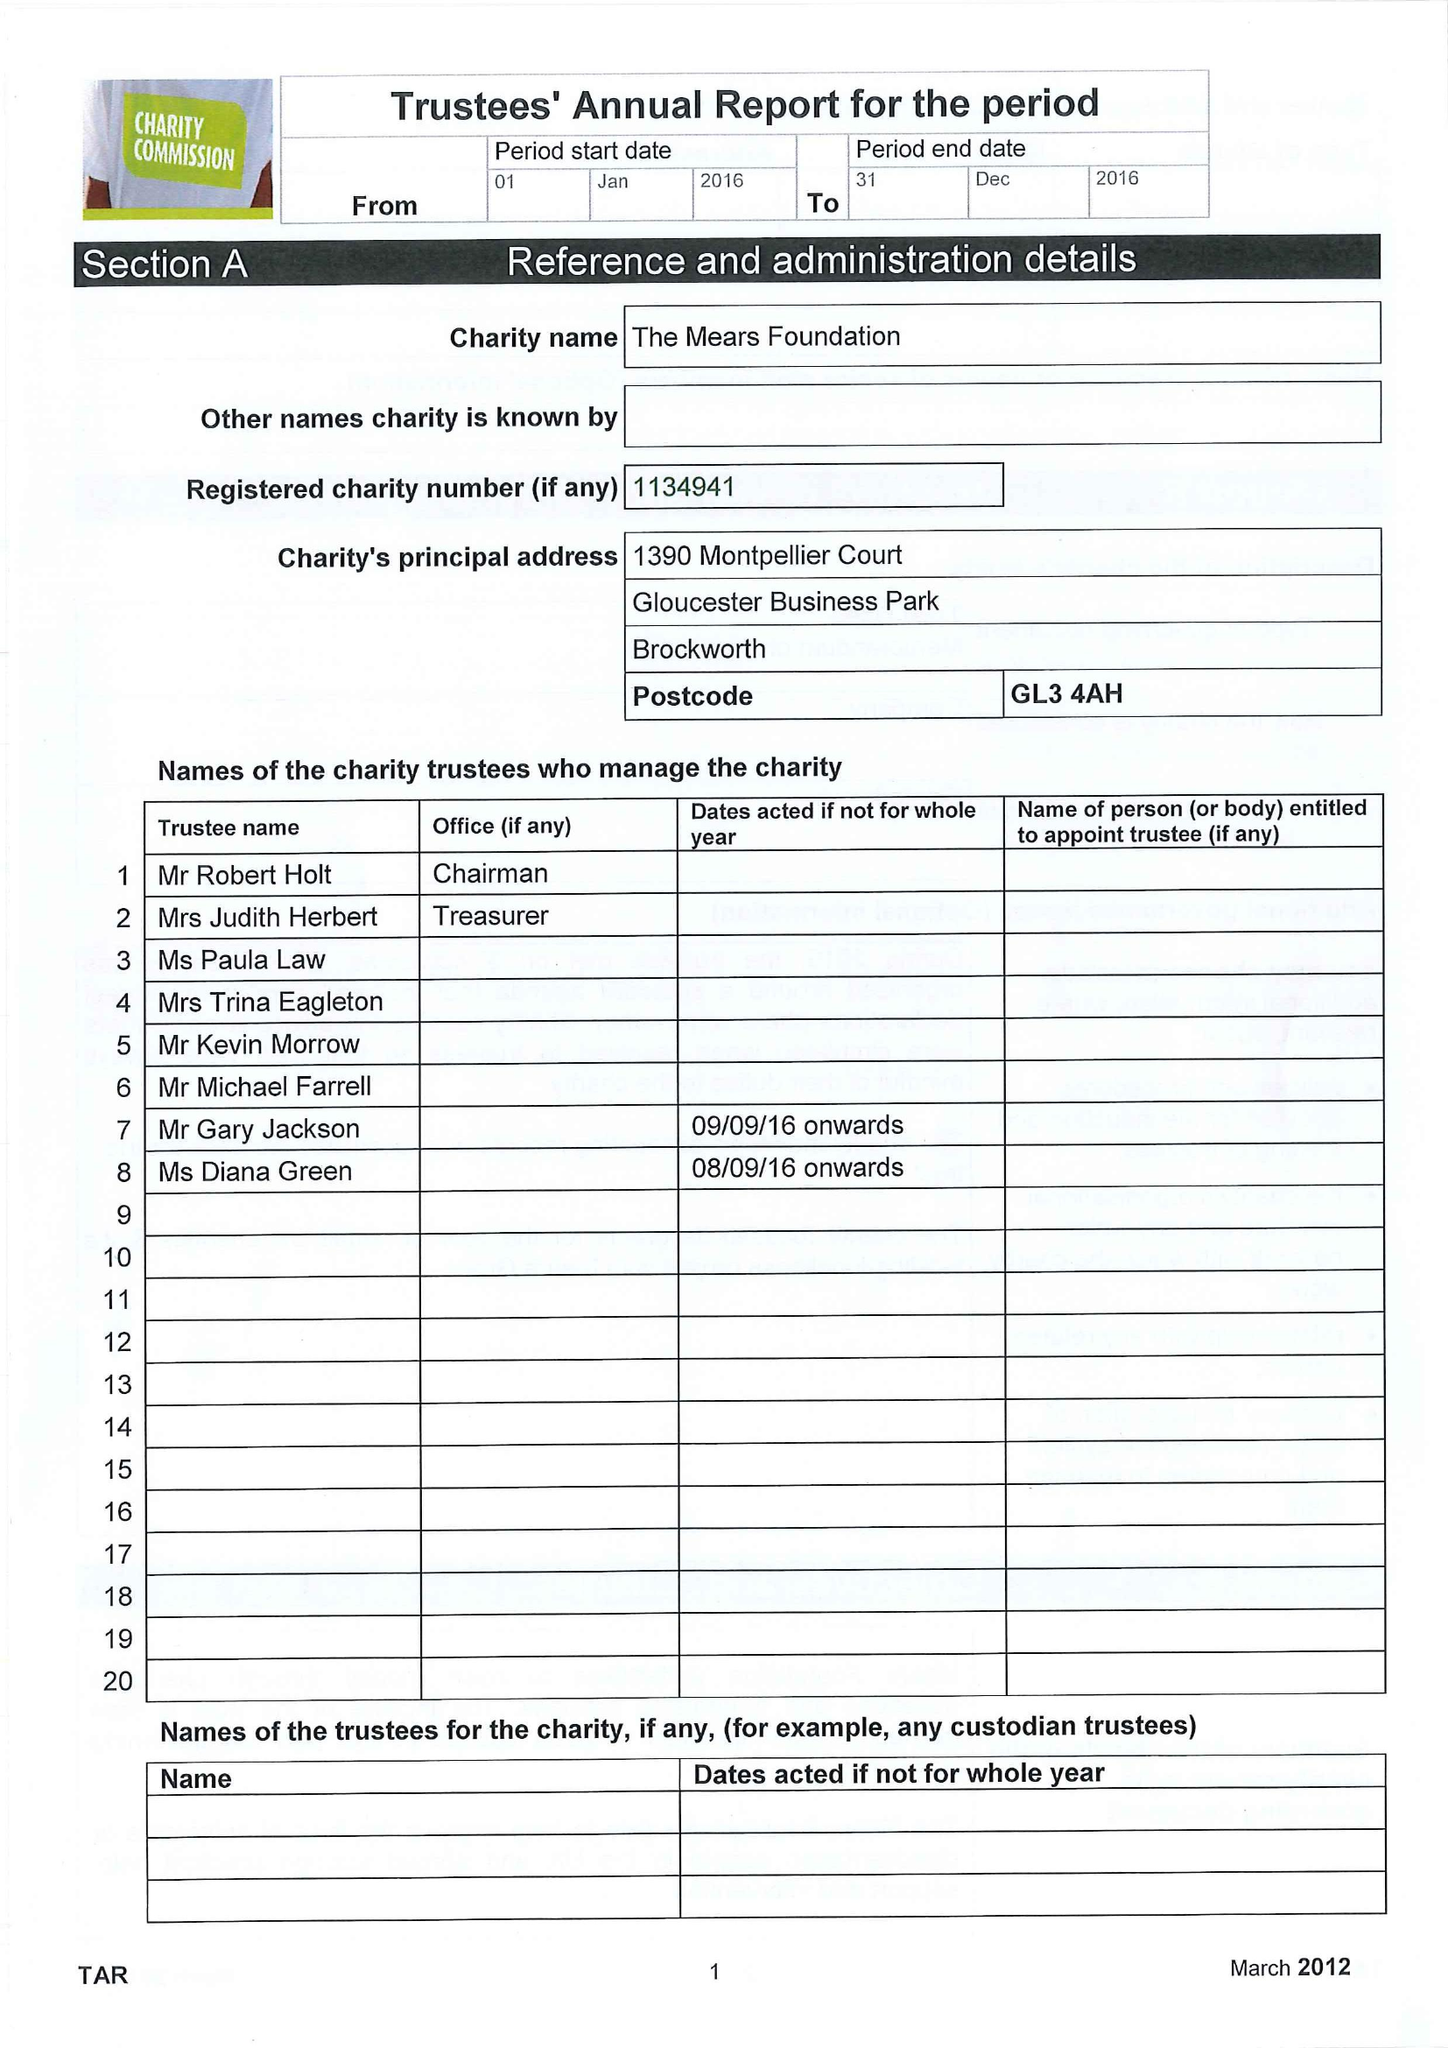What is the value for the report_date?
Answer the question using a single word or phrase. 2016-12-31 